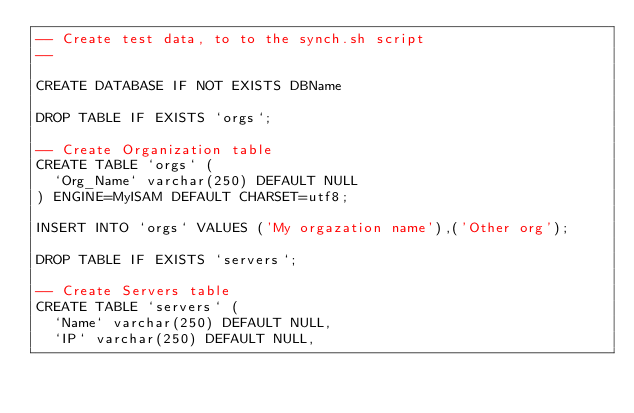Convert code to text. <code><loc_0><loc_0><loc_500><loc_500><_SQL_>-- Create test data, to to the synch.sh script
--

CREATE DATABASE IF NOT EXISTS DBName

DROP TABLE IF EXISTS `orgs`;

-- Create Organization table
CREATE TABLE `orgs` (
  `Org_Name` varchar(250) DEFAULT NULL
) ENGINE=MyISAM DEFAULT CHARSET=utf8;

INSERT INTO `orgs` VALUES ('My orgazation name'),('Other org');

DROP TABLE IF EXISTS `servers`;

-- Create Servers table
CREATE TABLE `servers` (
  `Name` varchar(250) DEFAULT NULL,
  `IP` varchar(250) DEFAULT NULL,</code> 